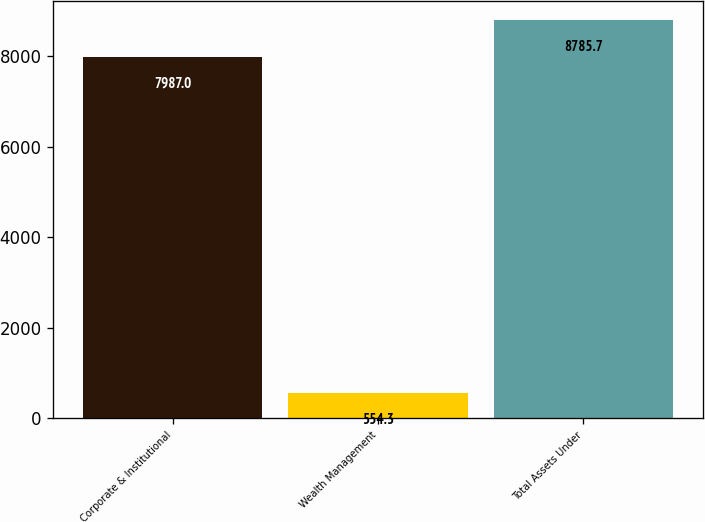<chart> <loc_0><loc_0><loc_500><loc_500><bar_chart><fcel>Corporate & Institutional<fcel>Wealth Management<fcel>Total Assets Under<nl><fcel>7987<fcel>554.3<fcel>8785.7<nl></chart> 